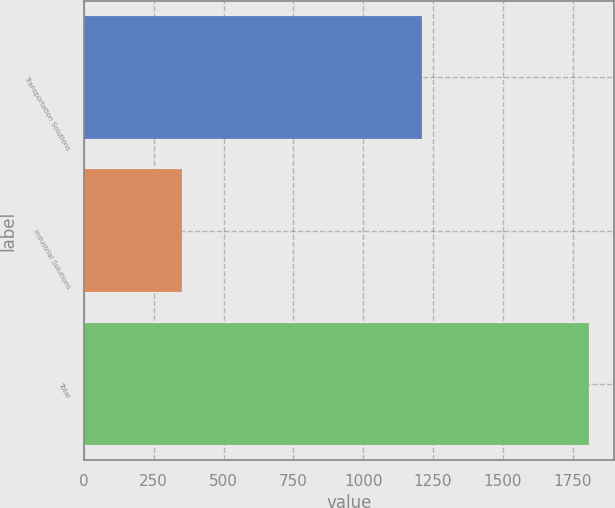Convert chart to OTSL. <chart><loc_0><loc_0><loc_500><loc_500><bar_chart><fcel>Transportation Solutions<fcel>Industrial Solutions<fcel>Total<nl><fcel>1209<fcel>353<fcel>1808<nl></chart> 